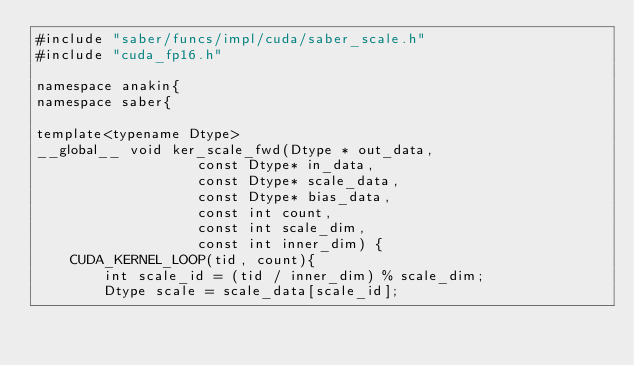<code> <loc_0><loc_0><loc_500><loc_500><_Cuda_>#include "saber/funcs/impl/cuda/saber_scale.h"
#include "cuda_fp16.h"

namespace anakin{
namespace saber{

template<typename Dtype>
__global__ void ker_scale_fwd(Dtype * out_data,
                   const Dtype* in_data,
                   const Dtype* scale_data,
                   const Dtype* bias_data,
                   const int count,
                   const int scale_dim,
                   const int inner_dim) {
    CUDA_KERNEL_LOOP(tid, count){
        int scale_id = (tid / inner_dim) % scale_dim;
        Dtype scale = scale_data[scale_id];</code> 